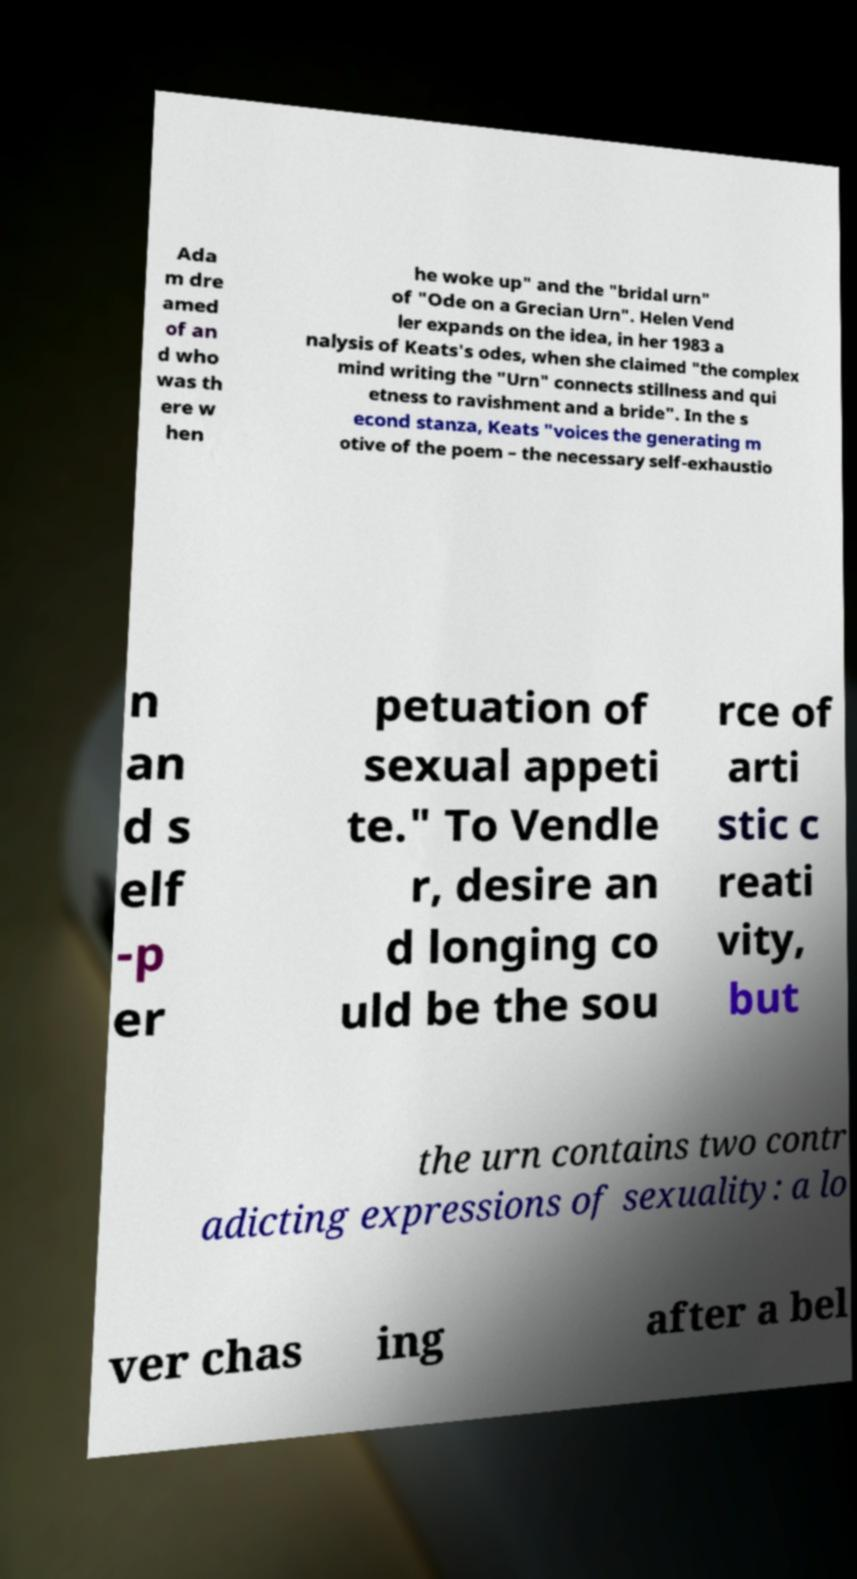Please read and relay the text visible in this image. What does it say? Ada m dre amed of an d who was th ere w hen he woke up" and the "bridal urn" of "Ode on a Grecian Urn". Helen Vend ler expands on the idea, in her 1983 a nalysis of Keats's odes, when she claimed "the complex mind writing the "Urn" connects stillness and qui etness to ravishment and a bride". In the s econd stanza, Keats "voices the generating m otive of the poem – the necessary self-exhaustio n an d s elf -p er petuation of sexual appeti te." To Vendle r, desire an d longing co uld be the sou rce of arti stic c reati vity, but the urn contains two contr adicting expressions of sexuality: a lo ver chas ing after a bel 